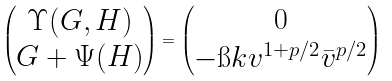Convert formula to latex. <formula><loc_0><loc_0><loc_500><loc_500>\begin{pmatrix} \Upsilon ( G , H ) \\ G + \Psi ( H ) \end{pmatrix} = \begin{pmatrix} 0 \\ - \i k v ^ { 1 + p / 2 } \bar { v } ^ { p / 2 } \end{pmatrix}</formula> 